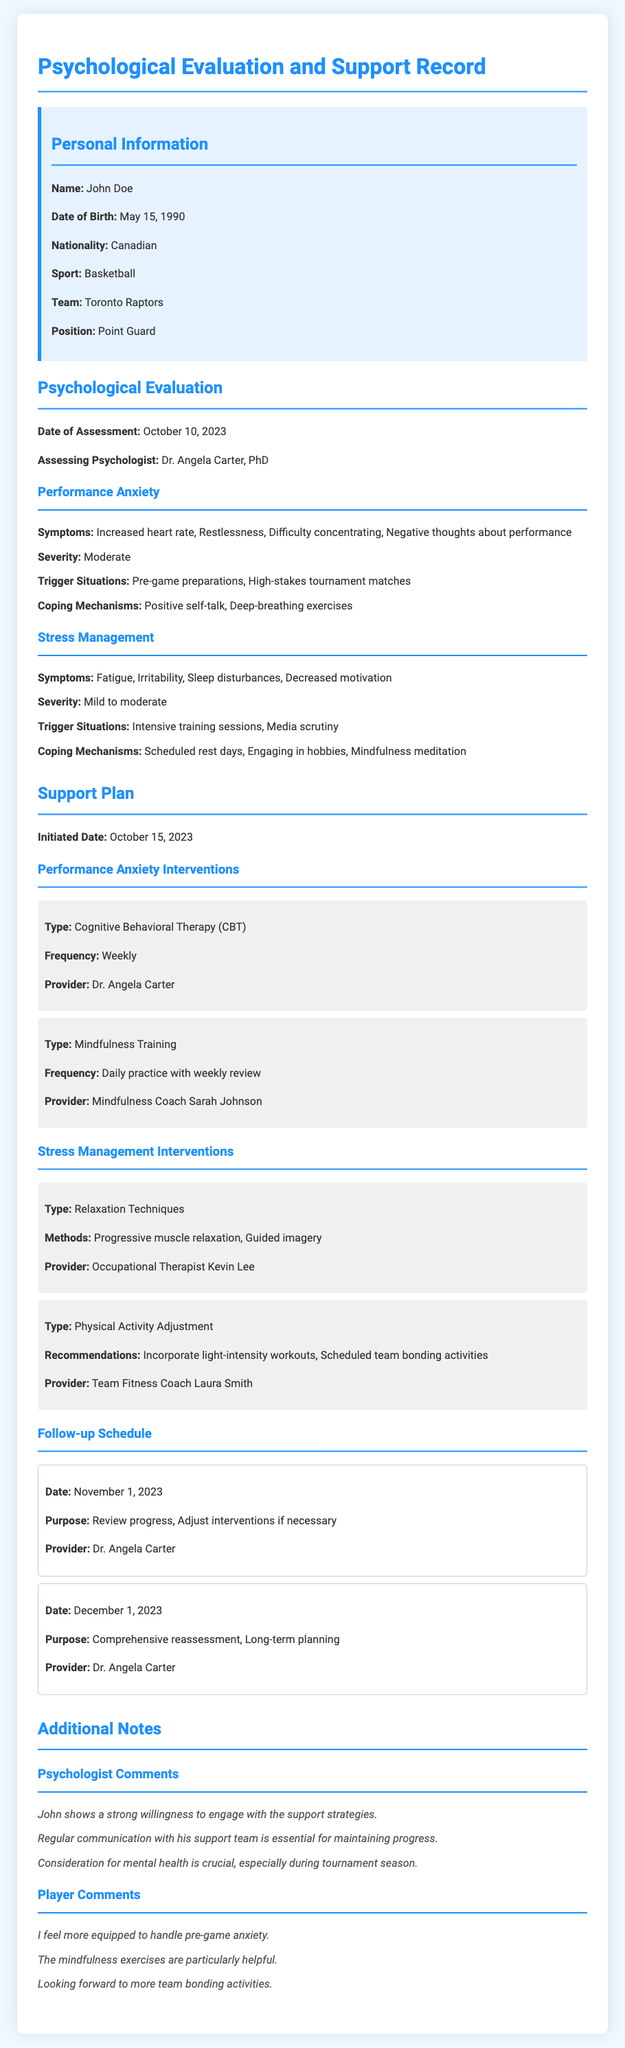What is the name of the player? The player's name is clearly stated in the personal information section of the document.
Answer: John Doe What is the sport played by the individual? The sport that John Doe is identified with is specified in the personal information section.
Answer: Basketball Who conducted the psychological assessment? The assessing psychologist's name is listed in the evaluation summary section of the document.
Answer: Dr. Angela Carter What is the severity level of performance anxiety? The severity of performance anxiety is mentioned in the evaluation summary under the performance anxiety section.
Answer: Moderate What intervention type is used for performance anxiety? The type of intervention for performance anxiety is detailed in the support plan section of the document.
Answer: Cognitive Behavioral Therapy (CBT) When is the first follow-up scheduled? The date for the first follow-up appointment is provided in the support plan's follow-up schedule section.
Answer: November 1, 2023 What coping mechanism is used for stress management? A coping mechanism for managing stress is outlined in the evaluation summary under the stress management section.
Answer: Scheduled rest days What is the primary symptom of stress management? The primary symptom associated with stress management is specified in the evaluation summary.
Answer: Fatigue What is the purpose of the comprehensive reassessment? The purpose of the comprehensive reassessment is indicated in the follow-up schedule section.
Answer: Long-term planning 